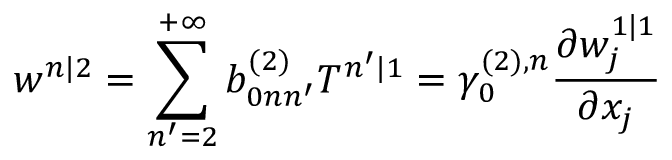<formula> <loc_0><loc_0><loc_500><loc_500>w ^ { n | 2 } = \sum _ { n ^ { \prime } = 2 } ^ { + \infty } b _ { 0 n n ^ { \prime } } ^ { ( 2 ) } T ^ { n ^ { \prime } | 1 } = \gamma _ { 0 } ^ { ( 2 ) , n } \frac { \partial w _ { j } ^ { 1 | 1 } } { \partial x _ { j } }</formula> 